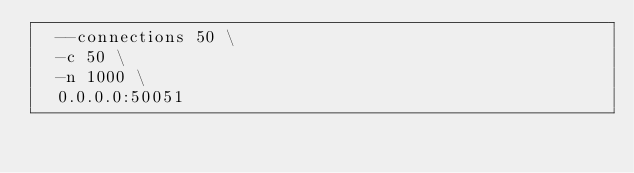<code> <loc_0><loc_0><loc_500><loc_500><_Bash_>  --connections 50 \
  -c 50 \
  -n 1000 \
  0.0.0.0:50051</code> 